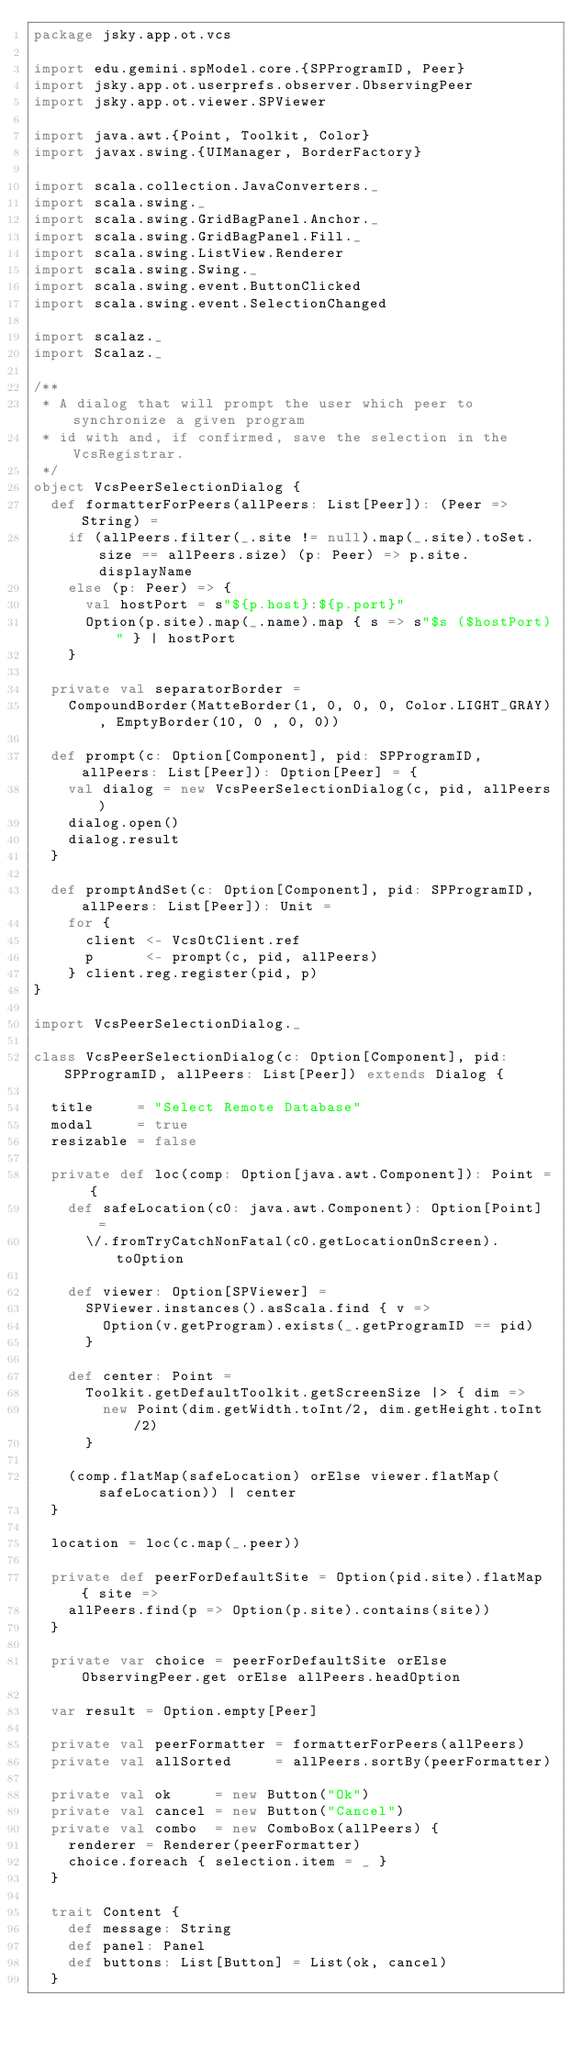<code> <loc_0><loc_0><loc_500><loc_500><_Scala_>package jsky.app.ot.vcs

import edu.gemini.spModel.core.{SPProgramID, Peer}
import jsky.app.ot.userprefs.observer.ObservingPeer
import jsky.app.ot.viewer.SPViewer

import java.awt.{Point, Toolkit, Color}
import javax.swing.{UIManager, BorderFactory}

import scala.collection.JavaConverters._
import scala.swing._
import scala.swing.GridBagPanel.Anchor._
import scala.swing.GridBagPanel.Fill._
import scala.swing.ListView.Renderer
import scala.swing.Swing._
import scala.swing.event.ButtonClicked
import scala.swing.event.SelectionChanged

import scalaz._
import Scalaz._

/**
 * A dialog that will prompt the user which peer to synchronize a given program
 * id with and, if confirmed, save the selection in the VcsRegistrar.
 */
object VcsPeerSelectionDialog {
  def formatterForPeers(allPeers: List[Peer]): (Peer => String) =
    if (allPeers.filter(_.site != null).map(_.site).toSet.size == allPeers.size) (p: Peer) => p.site.displayName
    else (p: Peer) => {
      val hostPort = s"${p.host}:${p.port}"
      Option(p.site).map(_.name).map { s => s"$s ($hostPort)" } | hostPort
    }

  private val separatorBorder =
    CompoundBorder(MatteBorder(1, 0, 0, 0, Color.LIGHT_GRAY), EmptyBorder(10, 0 , 0, 0))

  def prompt(c: Option[Component], pid: SPProgramID, allPeers: List[Peer]): Option[Peer] = {
    val dialog = new VcsPeerSelectionDialog(c, pid, allPeers)
    dialog.open()
    dialog.result
  }

  def promptAndSet(c: Option[Component], pid: SPProgramID, allPeers: List[Peer]): Unit =
    for {
      client <- VcsOtClient.ref
      p      <- prompt(c, pid, allPeers)
    } client.reg.register(pid, p)
}

import VcsPeerSelectionDialog._

class VcsPeerSelectionDialog(c: Option[Component], pid: SPProgramID, allPeers: List[Peer]) extends Dialog {

  title     = "Select Remote Database"
  modal     = true
  resizable = false

  private def loc(comp: Option[java.awt.Component]): Point = {
    def safeLocation(c0: java.awt.Component): Option[Point] =
      \/.fromTryCatchNonFatal(c0.getLocationOnScreen).toOption

    def viewer: Option[SPViewer] =
      SPViewer.instances().asScala.find { v =>
        Option(v.getProgram).exists(_.getProgramID == pid)
      }

    def center: Point =
      Toolkit.getDefaultToolkit.getScreenSize |> { dim =>
        new Point(dim.getWidth.toInt/2, dim.getHeight.toInt/2)
      }

    (comp.flatMap(safeLocation) orElse viewer.flatMap(safeLocation)) | center
  }

  location = loc(c.map(_.peer))

  private def peerForDefaultSite = Option(pid.site).flatMap { site =>
    allPeers.find(p => Option(p.site).contains(site))
  }

  private var choice = peerForDefaultSite orElse ObservingPeer.get orElse allPeers.headOption

  var result = Option.empty[Peer]

  private val peerFormatter = formatterForPeers(allPeers)
  private val allSorted     = allPeers.sortBy(peerFormatter)

  private val ok     = new Button("Ok")
  private val cancel = new Button("Cancel")
  private val combo  = new ComboBox(allPeers) {
    renderer = Renderer(peerFormatter)
    choice.foreach { selection.item = _ }
  }

  trait Content {
    def message: String
    def panel: Panel
    def buttons: List[Button] = List(ok, cancel)
  }
</code> 